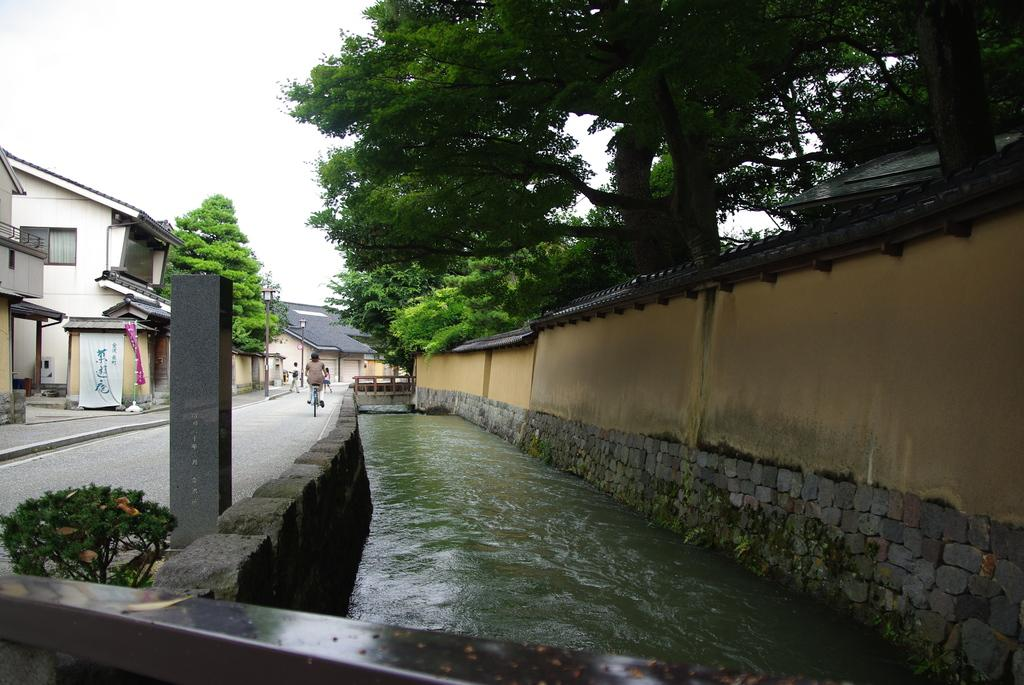What type of natural feature can be seen in the image? There is a lake in the image. What man-made structure is present in the image? There is a fence in the image. What type of building is visible in the image? There is a house and other buildings in the image. What type of lighting infrastructure is present in the image? There are light poles in the image. What type of vegetation is present in the image? There are trees in the image. What is the group of people doing in the image? The group of people is on the road in the image. What part of the sky is visible in the image? The sky is visible in the top left corner of the image. What time of day was the image taken? The image was taken during the day. What type of stove is being used by the group of people on the road in the image? There is no stove present in the image; the group of people is on the road. How does the balloon affect the lighting in the image? There is no balloon present in the image, so it cannot affect the lighting. 